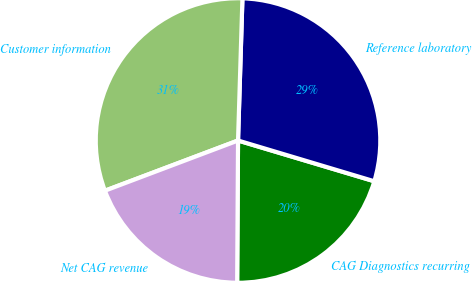Convert chart. <chart><loc_0><loc_0><loc_500><loc_500><pie_chart><fcel>CAG Diagnostics recurring<fcel>Reference laboratory<fcel>Customer information<fcel>Net CAG revenue<nl><fcel>20.47%<fcel>29.13%<fcel>31.23%<fcel>19.16%<nl></chart> 